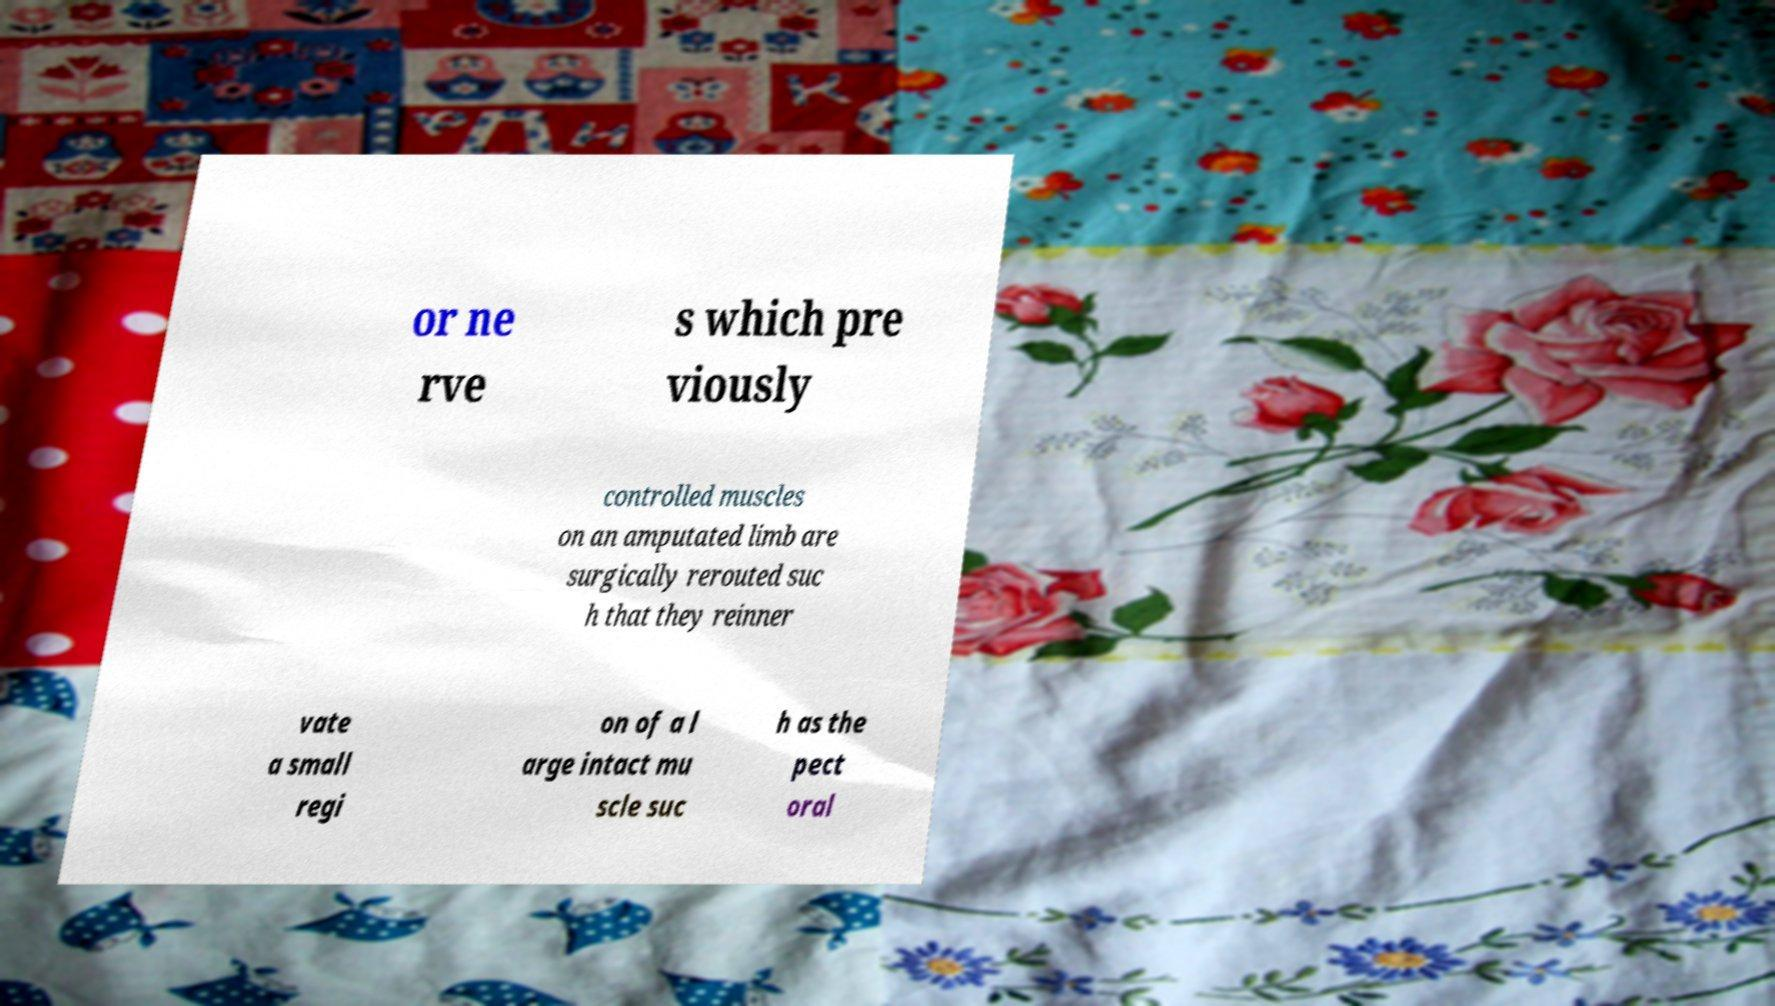Could you assist in decoding the text presented in this image and type it out clearly? or ne rve s which pre viously controlled muscles on an amputated limb are surgically rerouted suc h that they reinner vate a small regi on of a l arge intact mu scle suc h as the pect oral 